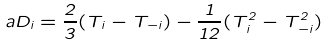Convert formula to latex. <formula><loc_0><loc_0><loc_500><loc_500>a D _ { i } = \frac { 2 } { 3 } ( T _ { i } - T _ { - i } ) - \frac { 1 } { 1 2 } ( T ^ { 2 } _ { i } - T ^ { 2 } _ { - i } )</formula> 